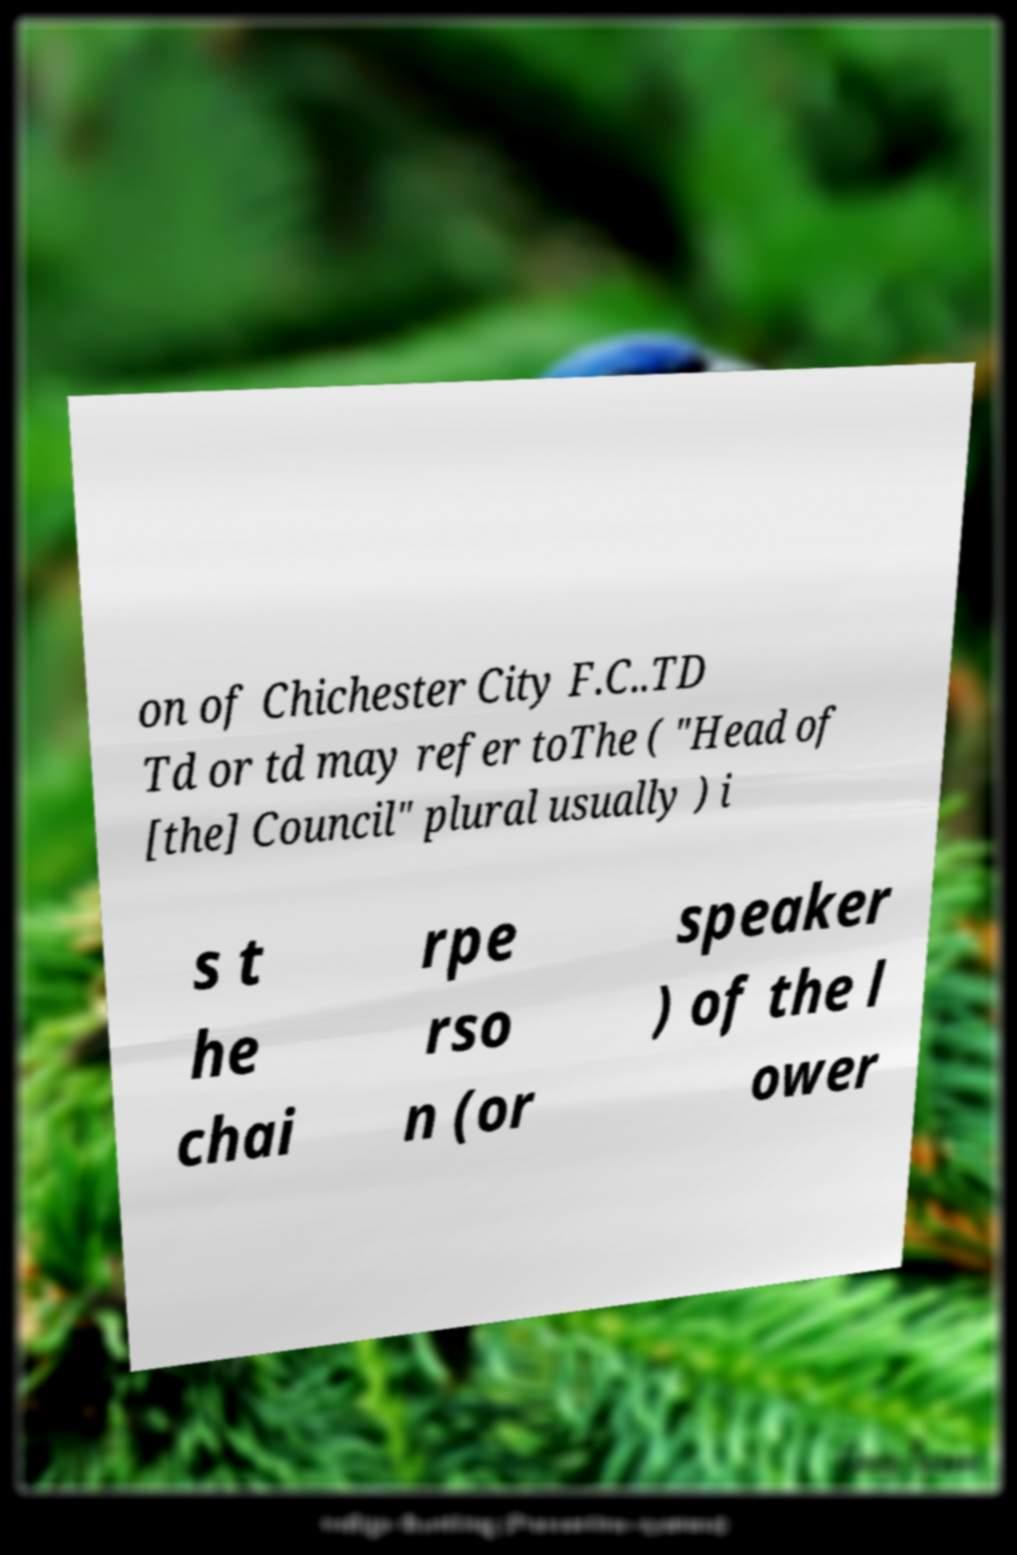I need the written content from this picture converted into text. Can you do that? on of Chichester City F.C..TD Td or td may refer toThe ( "Head of [the] Council" plural usually ) i s t he chai rpe rso n (or speaker ) of the l ower 